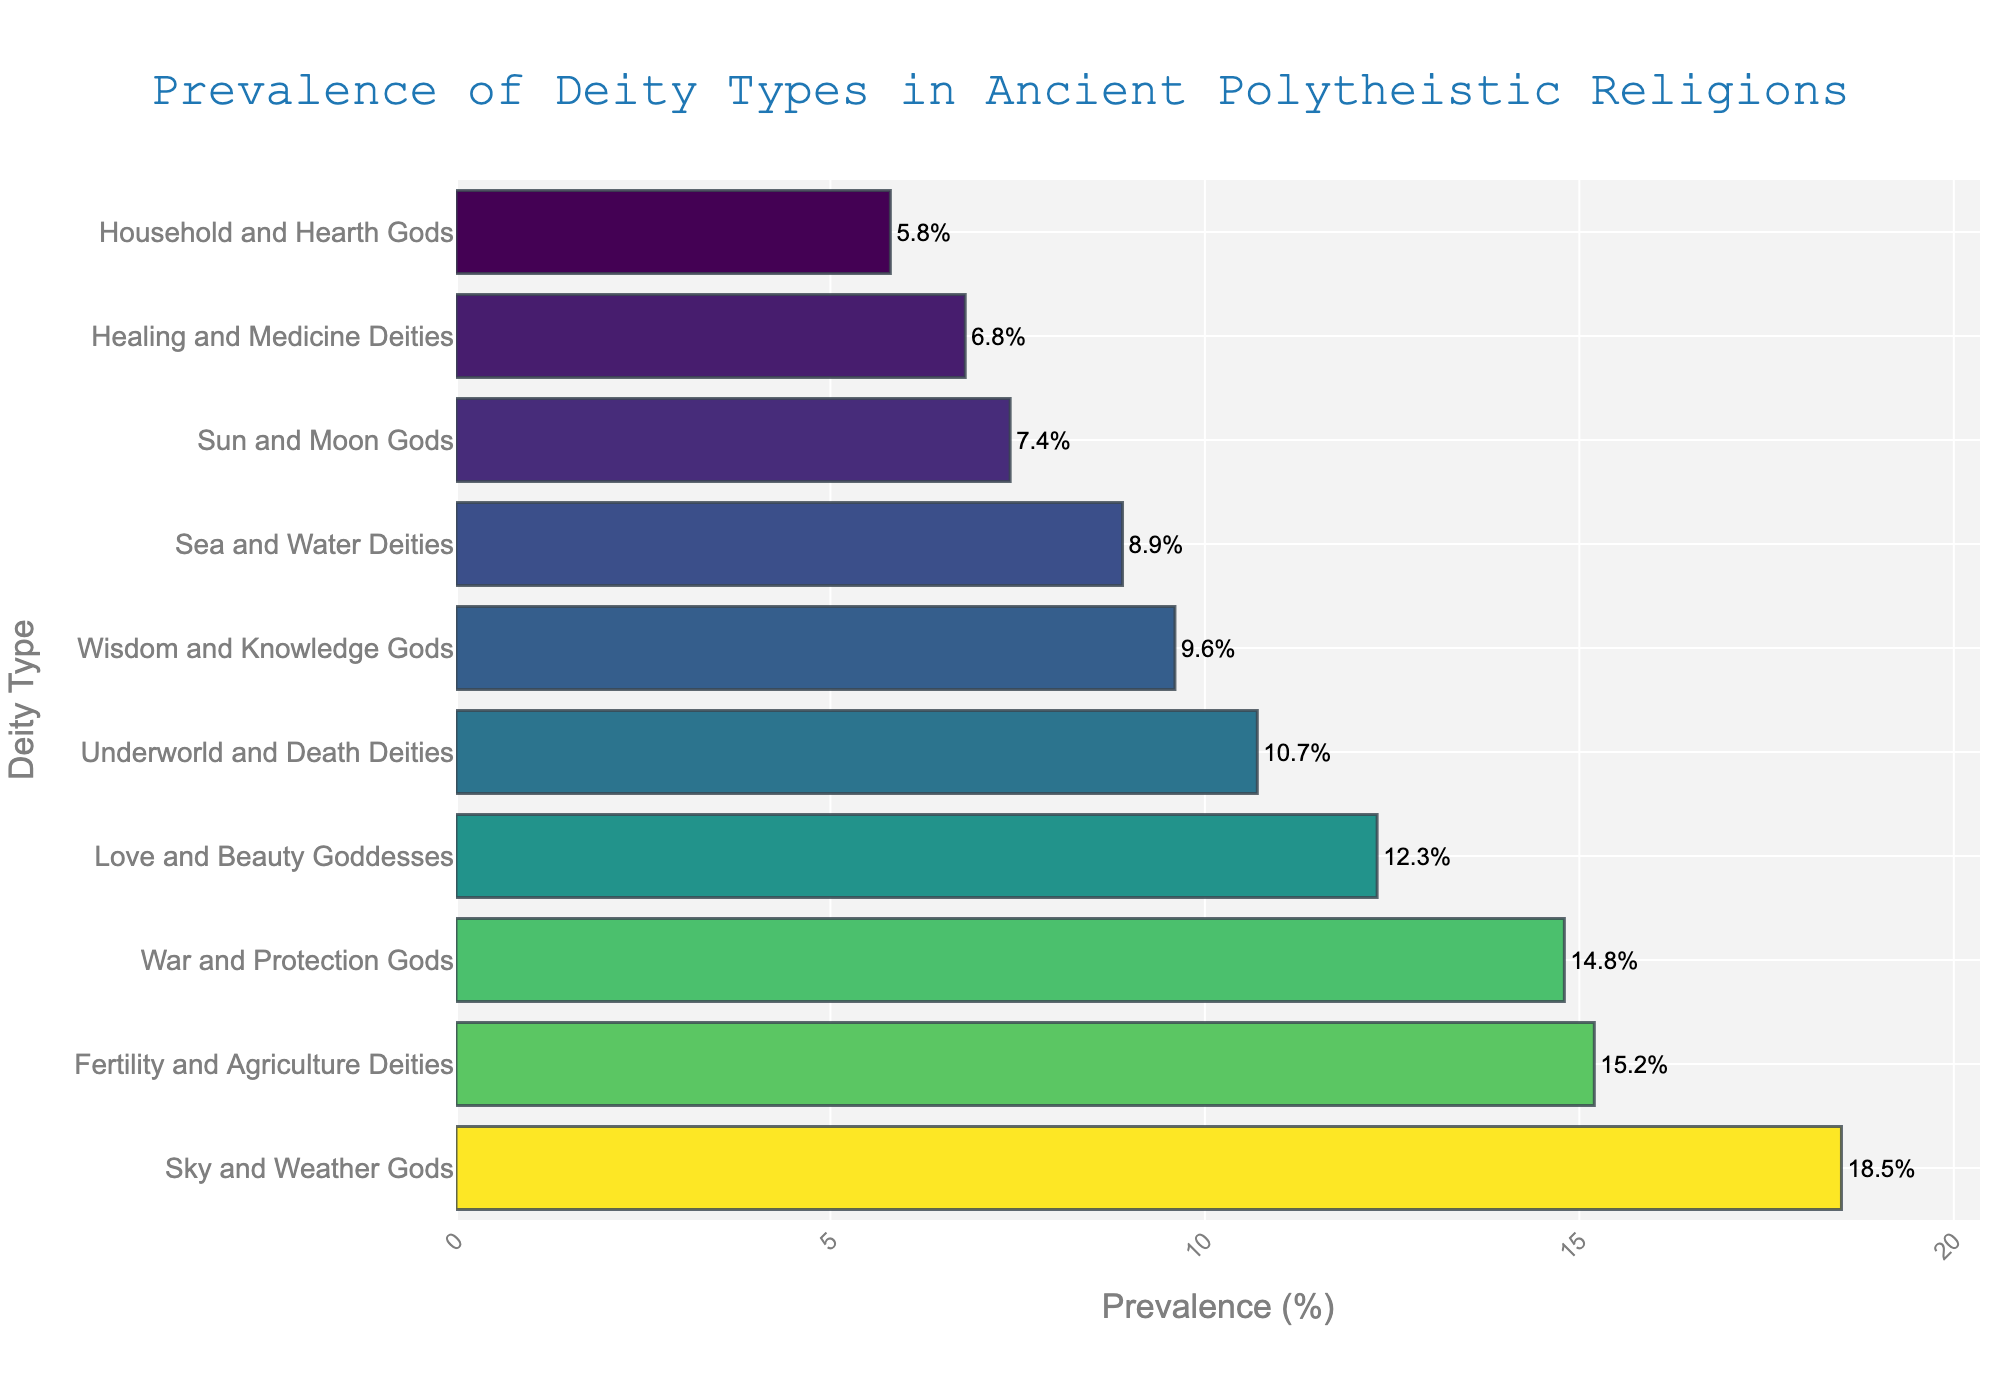Which deity type is the most prevalent? The figure shows that "Sky and Weather Gods" has the highest prevalence, indicated by the longest bar.
Answer: Sky and Weather Gods Which deity type has a prevalence close to 10%? The figure shows "Underworld and Death Deities" with a prevalence of 10.7%, indicated by a bar length close to the 10% mark.
Answer: Underworld and Death Deities How much more prevalent are Sky and Weather Gods compared to Healing and Medicine Deities? Sky and Weather Gods have a prevalence of 18.5%, and Healing and Medicine Deities have 6.8%. The difference is 18.5% - 6.8% = 11.7%.
Answer: 11.7% Which two deity types have a cumulative prevalence of over 30%? Sky and Weather Gods (18.5%) and Fertility and Agriculture Deities (15.2%) together have a cumulative prevalence of 18.5% + 15.2% = 33.7%, which is over 30%.
Answer: Sky and Weather Gods, Fertility and Agriculture Deities List all deity types that have a prevalence higher than 10%. The figure shows that "Sky and Weather Gods" (18.5%), "Fertility and Agriculture Deities" (15.2%), "War and Protection Gods" (14.8%), "Love and Beauty Goddesses" (12.3%), and "Underworld and Death Deities" (10.7%) all have prevalence values above 10%.
Answer: Sky and Weather Gods, Fertility and Agriculture Deities, War and Protection Gods, Love and Beauty Goddesses, Underworld and Death Deities Which deity type has the lowest prevalence, and what is its value? The shortest bar, which represents the "Household and Hearth Gods," shows a value of 5.8%.
Answer: Household and Hearth Gods, 5.8% Compare the prevalence of Wisdom and Knowledge Gods to Sea and Water Deities. Which is higher and by how much? Wisdom and Knowledge Gods have a prevalence of 9.6%, whereas Sea and Water Deities have 8.9%. The difference is 9.6% - 8.9% = 0.7%, so Wisdom and Knowledge Gods are higher by 0.7%.
Answer: Wisdom and Knowledge Gods, 0.7% What is the average prevalence of War and Protection Gods, Love and Beauty Goddesses, and Wisdom and Knowledge Gods? The prevalences are War and Protection Gods (14.8%), Love and Beauty Goddesses (12.3%), and Wisdom and Knowledge Gods (9.6%). The average is (14.8 + 12.3 + 9.6) / 3 = 12.23%.
Answer: 12.23% Which three deity types together make up the smallest combined prevalence? The types are Healing and Medicine Deities (6.8%), Household and Hearth Gods (5.8%), and Sun and Moon Gods (7.4%). Their combined prevalence is 6.8% + 5.8% + 7.4% = 20%.
Answer: Healing and Medicine Deities, Household and Hearth Gods, Sun and Moon Gods 